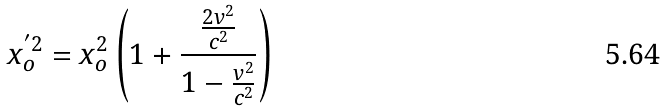Convert formula to latex. <formula><loc_0><loc_0><loc_500><loc_500>x _ { o } ^ { ^ { \prime } 2 } = x _ { o } ^ { 2 } \left ( 1 + \frac { \frac { 2 v ^ { 2 } } { c ^ { 2 } } } { 1 - \frac { v ^ { 2 } } { c ^ { 2 } } } \right )</formula> 